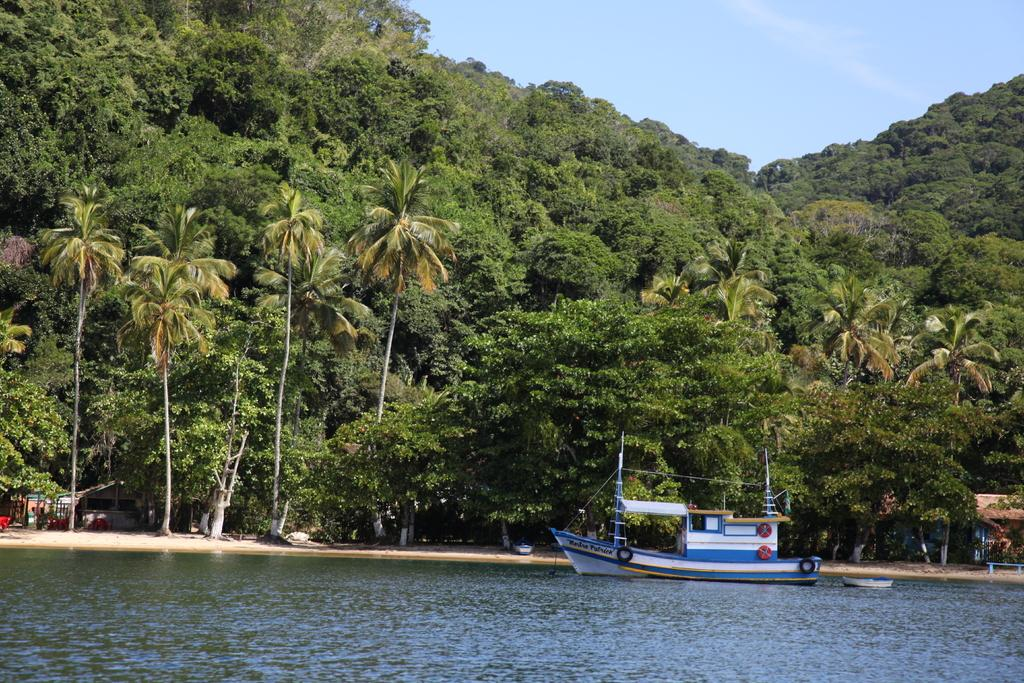What is the main subject of the image? There is a boat on a water body in the image. What can be seen in the background of the image? There are trees, buildings, and hills in the background of the image. What is the condition of the sky in the image? The sky is clear in the image. What type of drink is being offered to the person with a sore throat in the image? There is no person with a sore throat or any drink present in the image. What type of cloth is draped over the boat in the image? There is no cloth draped over the boat in the image. 